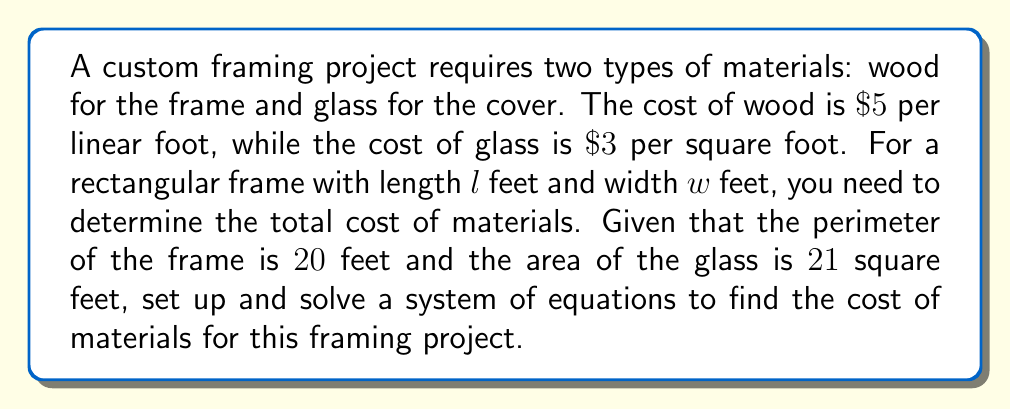What is the answer to this math problem? Let's approach this step-by-step:

1) First, let's set up equations based on the given information:

   Perimeter equation: $2l + 2w = 20$
   Area equation: $lw = 21$

2) Simplify the perimeter equation:
   $l + w = 10$

3) Now we have a system of two equations:
   $$\begin{cases}
   l + w = 10 \\
   lw = 21
   \end{cases}$$

4) Solve for $w$ in the first equation:
   $w = 10 - l$

5) Substitute this into the second equation:
   $l(10-l) = 21$
   $10l - l^2 = 21$
   $l^2 - 10l + 21 = 0$

6) This is a quadratic equation. Solve using the quadratic formula:
   $l = \frac{10 \pm \sqrt{100 - 4(1)(21)}}{2(1)} = \frac{10 \pm \sqrt{16}}{2} = \frac{10 \pm 4}{2}$

7) This gives us two solutions: $l = 7$ or $l = 3$. Since $l > w$ for a rectangle, $l = 7$ and $w = 3$.

8) Now calculate the cost:
   Wood cost: $20 \text{ feet} \times \$5/\text{ft} = \$100$
   Glass cost: $21 \text{ sq ft} \times \$3/\text{sq ft} = \$63$

9) Total cost: $\$100 + \$63 = \$163$
Answer: $\$163$ 